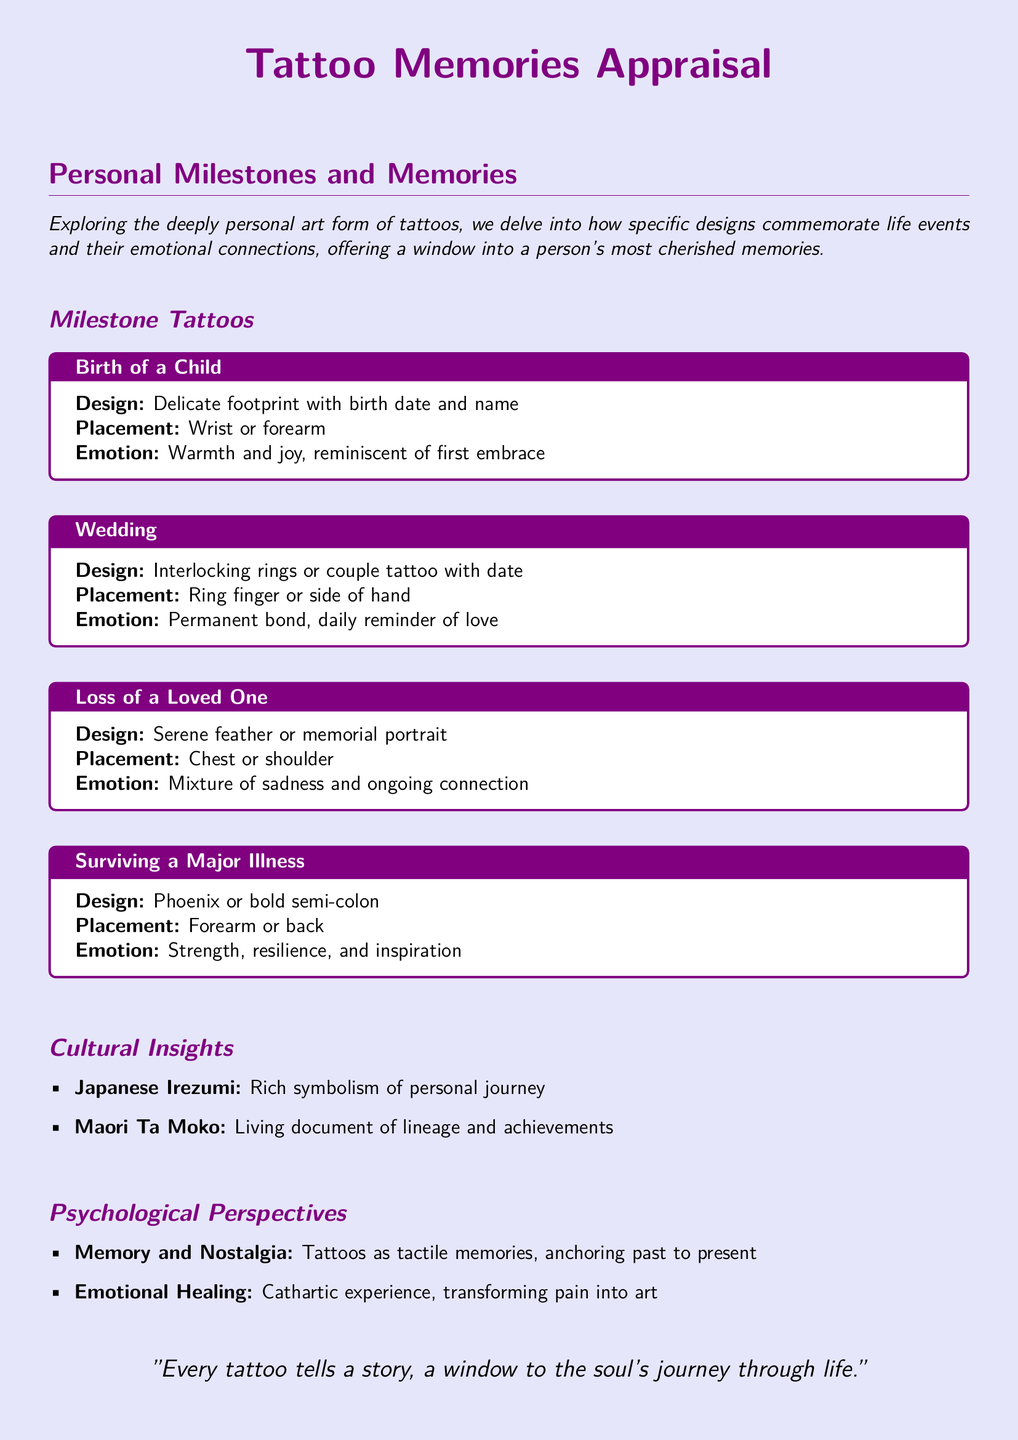What is the design for the birth of a child tattoo? The design for the birth of a child tattoo includes a delicate footprint with birth date and name.
Answer: Delicate footprint with birth date and name Where is the wedding tattoo usually placed? The wedding tattoo is typically placed on the ring finger or side of the hand.
Answer: Ring finger or side of hand What emotion is associated with the loss of a loved one tattoo? The emotion associated with the loss of a loved one tattoo is a mixture of sadness and ongoing connection.
Answer: Mixture of sadness and ongoing connection What does the phoenix tattoo symbolize? The phoenix tattoo symbolizes strength, resilience, and inspiration related to surviving a major illness.
Answer: Strength, resilience, and inspiration What is the cultural significance of Japanese Irezumi? Japanese Irezumi has rich symbolism representing a personal journey.
Answer: Rich symbolism of personal journey How does the document describe tattoos in relation to emotional healing? The document describes tattoos as a cathartic experience, transforming pain into art in relation to emotional healing.
Answer: Cathartic experience, transforming pain into art What is stated about every tattoo in the document's closing quote? The closing quote states that every tattoo tells a story and provides a window to the soul's journey.
Answer: Every tattoo tells a story, a window to the soul's journey through life How many major life events are highlighted in the milestone tattoos section? The milestone tattoos section highlights four major life events.
Answer: Four major life events 